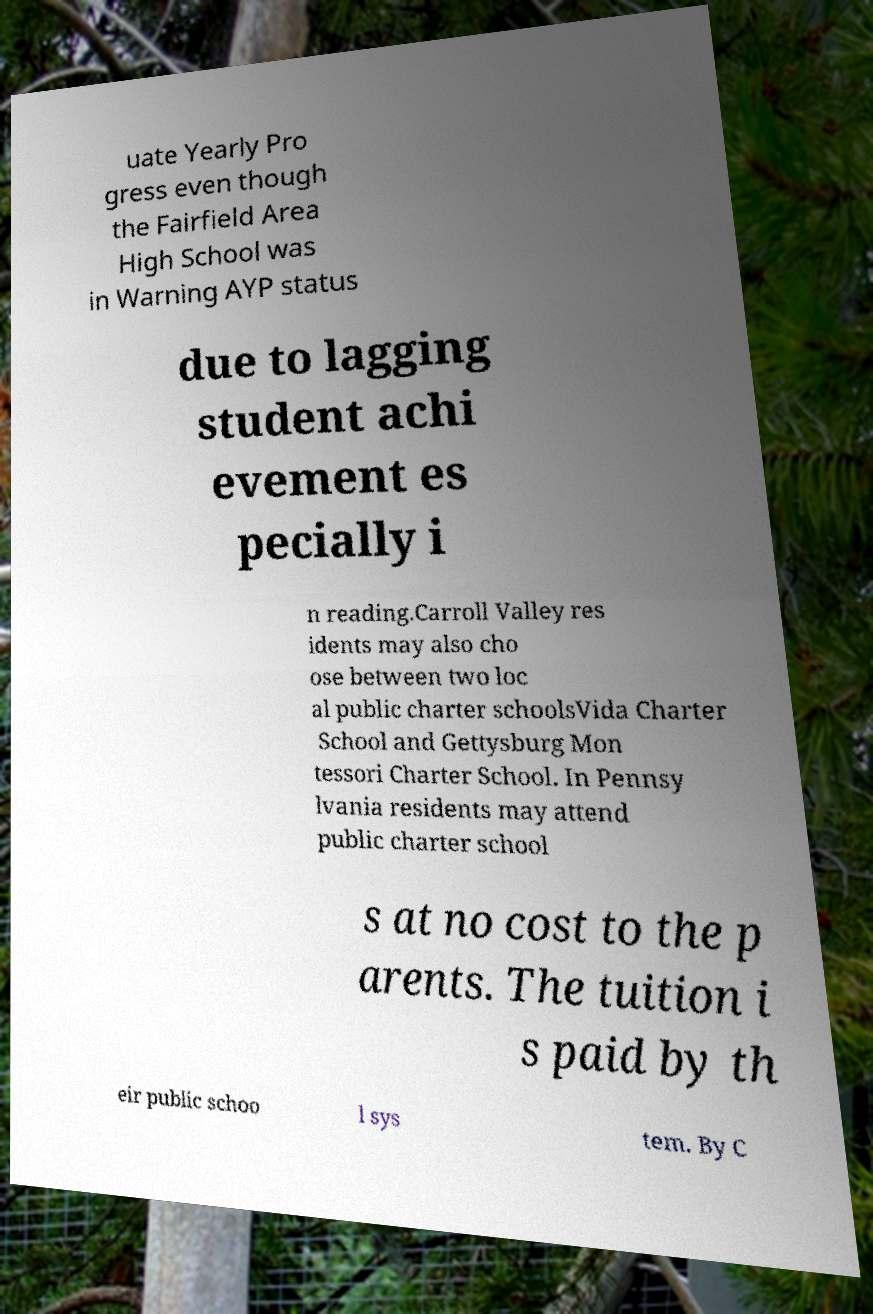I need the written content from this picture converted into text. Can you do that? uate Yearly Pro gress even though the Fairfield Area High School was in Warning AYP status due to lagging student achi evement es pecially i n reading.Carroll Valley res idents may also cho ose between two loc al public charter schoolsVida Charter School and Gettysburg Mon tessori Charter School. In Pennsy lvania residents may attend public charter school s at no cost to the p arents. The tuition i s paid by th eir public schoo l sys tem. By C 